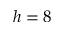Convert formula to latex. <formula><loc_0><loc_0><loc_500><loc_500>h = 8</formula> 